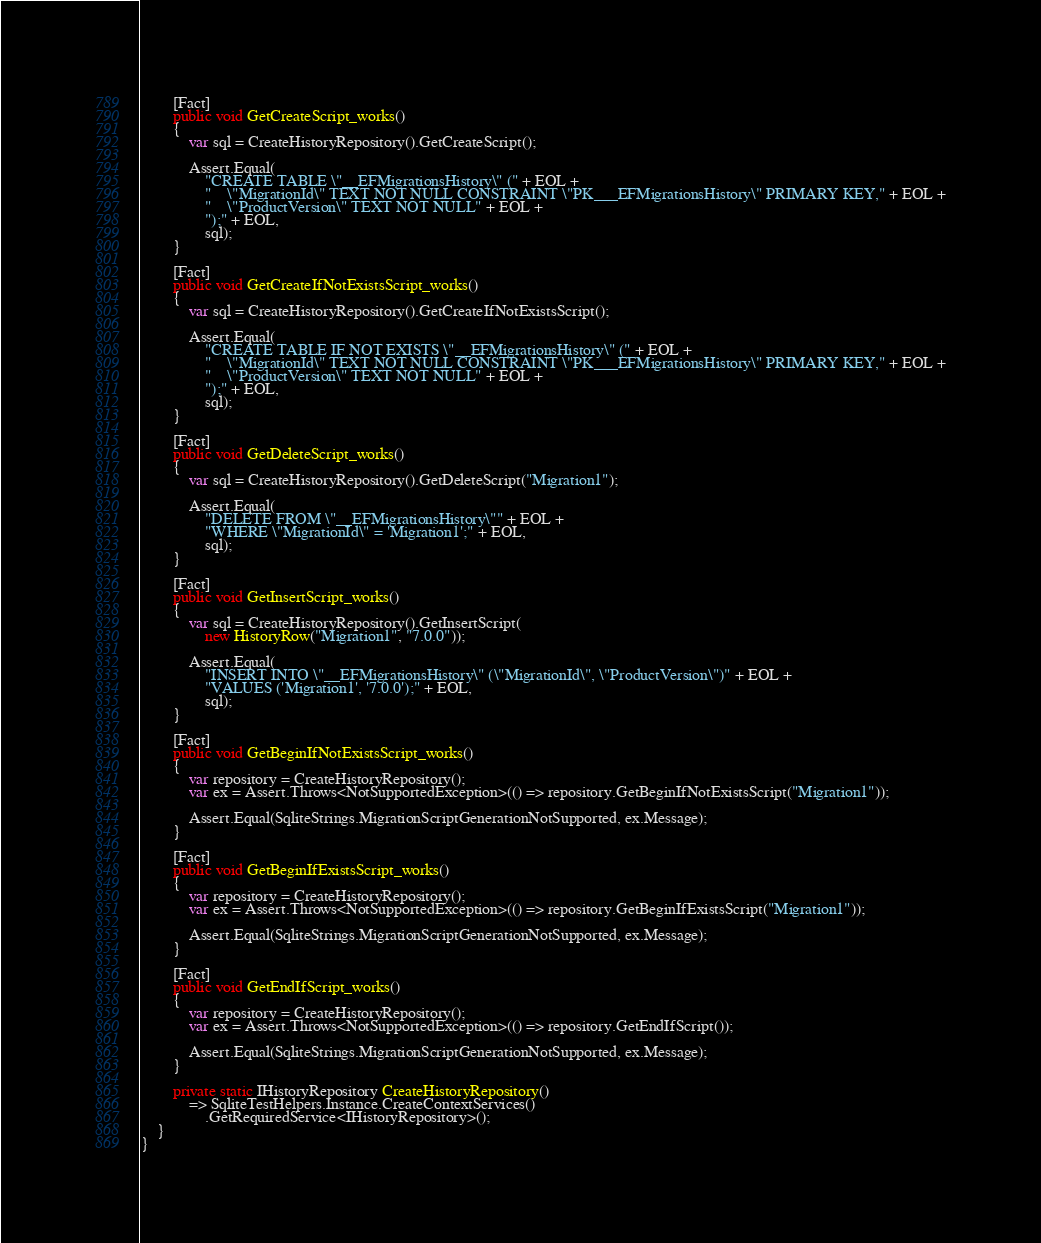Convert code to text. <code><loc_0><loc_0><loc_500><loc_500><_C#_>
        [Fact]
        public void GetCreateScript_works()
        {
            var sql = CreateHistoryRepository().GetCreateScript();

            Assert.Equal(
                "CREATE TABLE \"__EFMigrationsHistory\" (" + EOL +
                "    \"MigrationId\" TEXT NOT NULL CONSTRAINT \"PK___EFMigrationsHistory\" PRIMARY KEY," + EOL +
                "    \"ProductVersion\" TEXT NOT NULL" + EOL +
                ");" + EOL,
                sql);
        }

        [Fact]
        public void GetCreateIfNotExistsScript_works()
        {
            var sql = CreateHistoryRepository().GetCreateIfNotExistsScript();

            Assert.Equal(
                "CREATE TABLE IF NOT EXISTS \"__EFMigrationsHistory\" (" + EOL +
                "    \"MigrationId\" TEXT NOT NULL CONSTRAINT \"PK___EFMigrationsHistory\" PRIMARY KEY," + EOL +
                "    \"ProductVersion\" TEXT NOT NULL" + EOL +
                ");" + EOL,
                sql);
        }

        [Fact]
        public void GetDeleteScript_works()
        {
            var sql = CreateHistoryRepository().GetDeleteScript("Migration1");

            Assert.Equal(
                "DELETE FROM \"__EFMigrationsHistory\"" + EOL +
                "WHERE \"MigrationId\" = 'Migration1';" + EOL,
                sql);
        }

        [Fact]
        public void GetInsertScript_works()
        {
            var sql = CreateHistoryRepository().GetInsertScript(
                new HistoryRow("Migration1", "7.0.0"));

            Assert.Equal(
                "INSERT INTO \"__EFMigrationsHistory\" (\"MigrationId\", \"ProductVersion\")" + EOL +
                "VALUES ('Migration1', '7.0.0');" + EOL,
                sql);
        }

        [Fact]
        public void GetBeginIfNotExistsScript_works()
        {
            var repository = CreateHistoryRepository();
            var ex = Assert.Throws<NotSupportedException>(() => repository.GetBeginIfNotExistsScript("Migration1"));

            Assert.Equal(SqliteStrings.MigrationScriptGenerationNotSupported, ex.Message);
        }

        [Fact]
        public void GetBeginIfExistsScript_works()
        {
            var repository = CreateHistoryRepository();
            var ex = Assert.Throws<NotSupportedException>(() => repository.GetBeginIfExistsScript("Migration1"));

            Assert.Equal(SqliteStrings.MigrationScriptGenerationNotSupported, ex.Message);
        }

        [Fact]
        public void GetEndIfScript_works()
        {
            var repository = CreateHistoryRepository();
            var ex = Assert.Throws<NotSupportedException>(() => repository.GetEndIfScript());

            Assert.Equal(SqliteStrings.MigrationScriptGenerationNotSupported, ex.Message);
        }

        private static IHistoryRepository CreateHistoryRepository()
            => SqliteTestHelpers.Instance.CreateContextServices()
                .GetRequiredService<IHistoryRepository>();
    }
}
</code> 